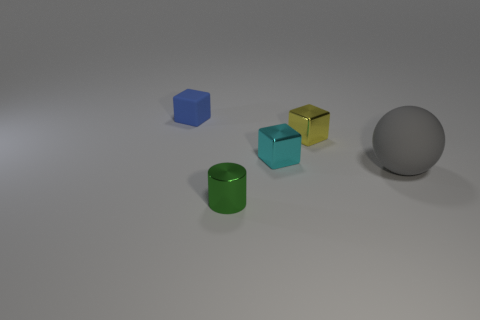Is there any other thing that has the same shape as the small green metal object?
Offer a terse response. No. Does the matte object that is on the right side of the small blue block have the same size as the cube that is right of the cyan object?
Your answer should be compact. No. There is a thing in front of the rubber thing to the right of the shiny thing that is in front of the tiny cyan metallic object; what is its material?
Offer a terse response. Metal. How big is the rubber thing that is to the right of the metal object in front of the rubber object that is in front of the blue block?
Offer a very short reply. Large. There is a yellow object behind the thing in front of the matte ball; what is it made of?
Give a very brief answer. Metal. Are there an equal number of small metal things that are to the right of the cyan object and yellow things?
Ensure brevity in your answer.  Yes. Are there any big gray rubber things that are behind the tiny thing that is in front of the large gray rubber object?
Keep it short and to the point. Yes. Is the small object in front of the gray object made of the same material as the cyan thing?
Provide a succinct answer. Yes. Are there an equal number of blue matte things in front of the yellow shiny object and tiny yellow objects that are in front of the gray ball?
Your answer should be very brief. Yes. How big is the thing in front of the rubber object in front of the blue thing?
Offer a terse response. Small. 